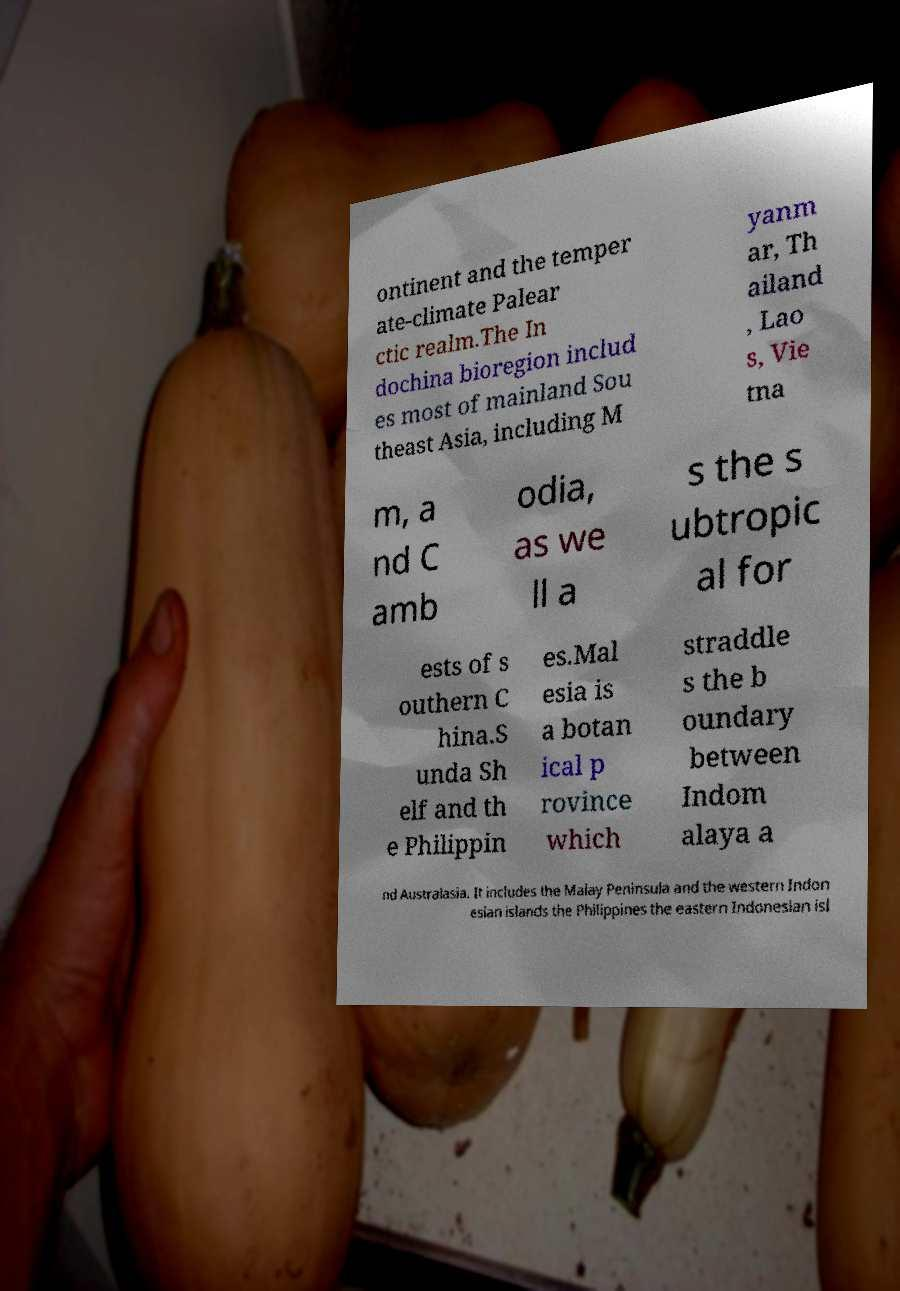Can you accurately transcribe the text from the provided image for me? ontinent and the temper ate-climate Palear ctic realm.The In dochina bioregion includ es most of mainland Sou theast Asia, including M yanm ar, Th ailand , Lao s, Vie tna m, a nd C amb odia, as we ll a s the s ubtropic al for ests of s outhern C hina.S unda Sh elf and th e Philippin es.Mal esia is a botan ical p rovince which straddle s the b oundary between Indom alaya a nd Australasia. It includes the Malay Peninsula and the western Indon esian islands the Philippines the eastern Indonesian isl 